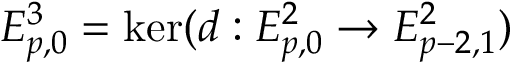Convert formula to latex. <formula><loc_0><loc_0><loc_500><loc_500>E _ { p , 0 } ^ { 3 } = \ker ( d \colon E _ { p , 0 } ^ { 2 } \to E _ { p - 2 , 1 } ^ { 2 } )</formula> 